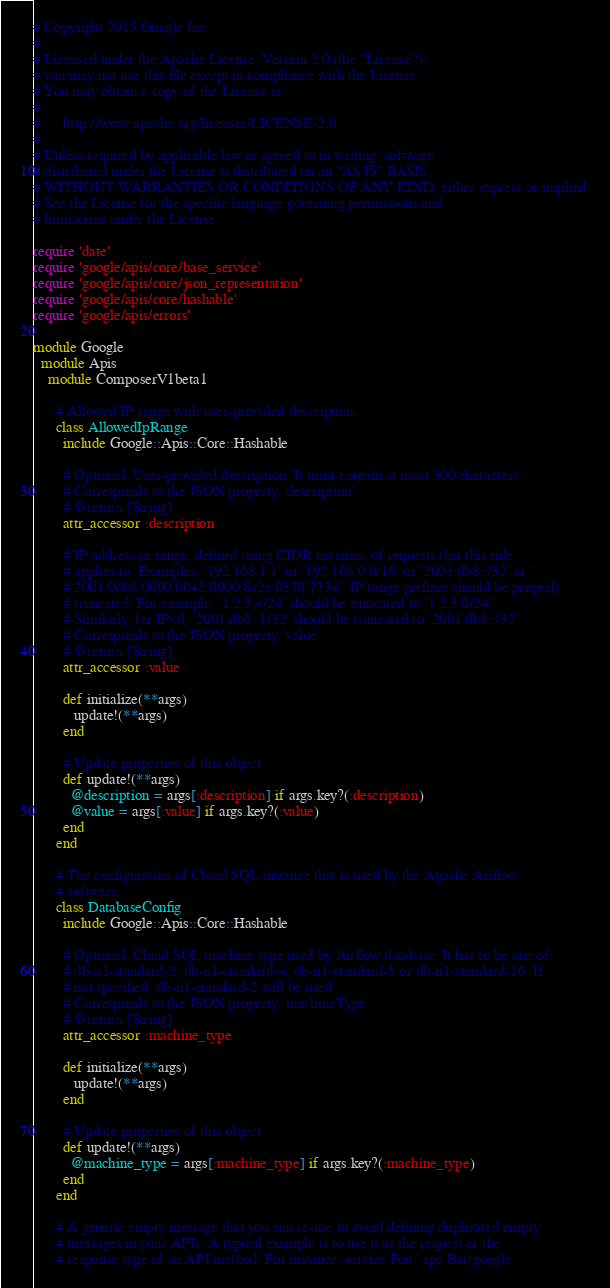Convert code to text. <code><loc_0><loc_0><loc_500><loc_500><_Ruby_># Copyright 2015 Google Inc.
#
# Licensed under the Apache License, Version 2.0 (the "License");
# you may not use this file except in compliance with the License.
# You may obtain a copy of the License at
#
#      http://www.apache.org/licenses/LICENSE-2.0
#
# Unless required by applicable law or agreed to in writing, software
# distributed under the License is distributed on an "AS IS" BASIS,
# WITHOUT WARRANTIES OR CONDITIONS OF ANY KIND, either express or implied.
# See the License for the specific language governing permissions and
# limitations under the License.

require 'date'
require 'google/apis/core/base_service'
require 'google/apis/core/json_representation'
require 'google/apis/core/hashable'
require 'google/apis/errors'

module Google
  module Apis
    module ComposerV1beta1
      
      # Allowed IP range with user-provided description.
      class AllowedIpRange
        include Google::Apis::Core::Hashable
      
        # Optional. User-provided description. It must contain at most 300 characters.
        # Corresponds to the JSON property `description`
        # @return [String]
        attr_accessor :description
      
        # IP address or range, defined using CIDR notation, of requests that this rule
        # applies to. Examples: `192.168.1.1` or `192.168.0.0/16` or `2001:db8::/32` or `
        # 2001:0db8:0000:0042:0000:8a2e:0370:7334`. IP range prefixes should be properly
        # truncated. For example, `1.2.3.4/24` should be truncated to `1.2.3.0/24`.
        # Similarly, for IPv6, `2001:db8::1/32` should be truncated to `2001:db8::/32`.
        # Corresponds to the JSON property `value`
        # @return [String]
        attr_accessor :value
      
        def initialize(**args)
           update!(**args)
        end
      
        # Update properties of this object
        def update!(**args)
          @description = args[:description] if args.key?(:description)
          @value = args[:value] if args.key?(:value)
        end
      end
      
      # The configuration of Cloud SQL instance that is used by the Apache Airflow
      # software.
      class DatabaseConfig
        include Google::Apis::Core::Hashable
      
        # Optional. Cloud SQL machine type used by Airflow database. It has to be one of:
        # db-n1-standard-2, db-n1-standard-4, db-n1-standard-8 or db-n1-standard-16. If
        # not specified, db-n1-standard-2 will be used.
        # Corresponds to the JSON property `machineType`
        # @return [String]
        attr_accessor :machine_type
      
        def initialize(**args)
           update!(**args)
        end
      
        # Update properties of this object
        def update!(**args)
          @machine_type = args[:machine_type] if args.key?(:machine_type)
        end
      end
      
      # A generic empty message that you can re-use to avoid defining duplicated empty
      # messages in your APIs. A typical example is to use it as the request or the
      # response type of an API method. For instance: service Foo ` rpc Bar(google.</code> 